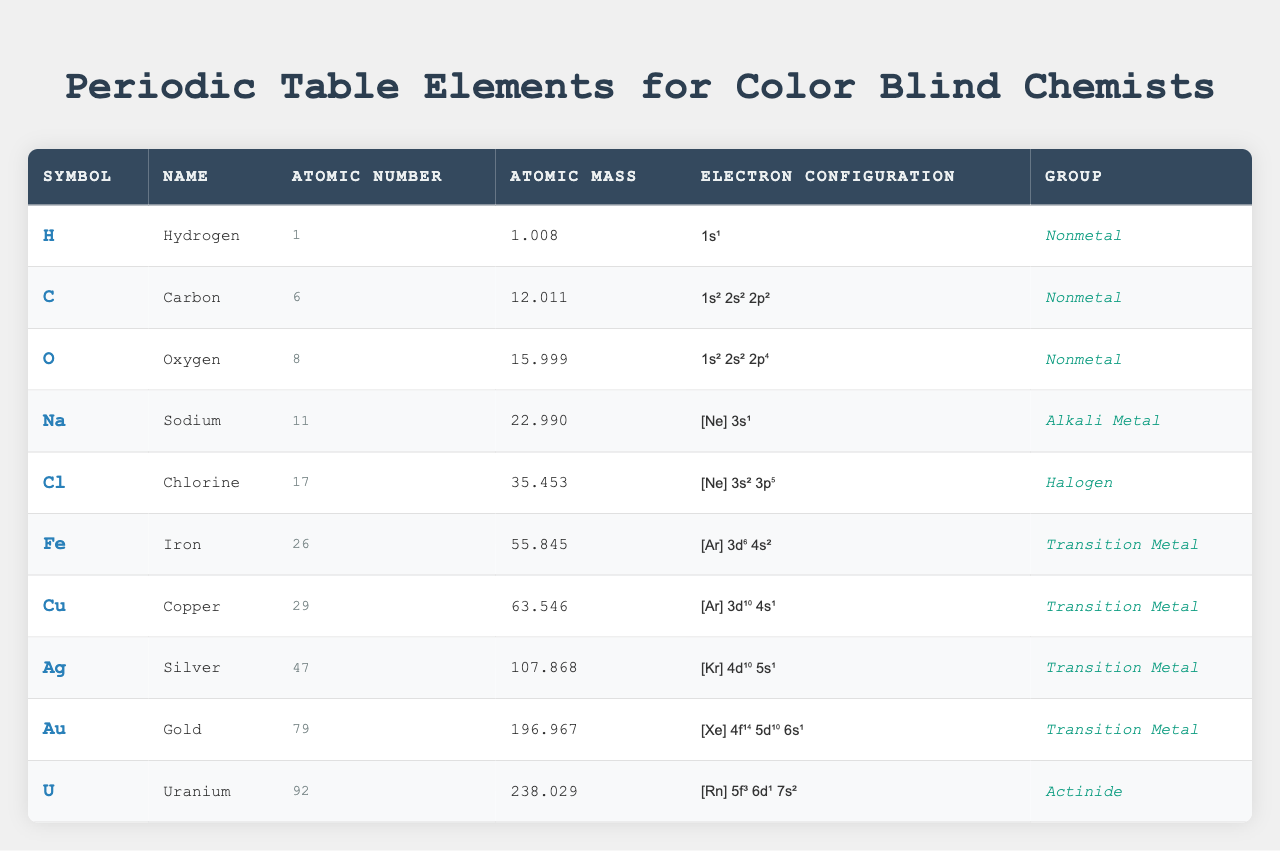What is the atomic mass of Carbon? The atomic mass is listed directly in the table for Carbon, which is 12.011.
Answer: 12.011 Which element has the highest atomic number? By scanning the atomic number column, Uranium is identified with the atomic number of 92, which is higher than all other listed elements.
Answer: Uranium Is Silver a Transition Metal? The group classification for Silver in the table indicates that it is categorized as a Transition Metal.
Answer: Yes What is the electron configuration of Sodium? Looking at the electron configuration column for Sodium, the configuration is listed as [Ne] 3s¹.
Answer: [Ne] 3s¹ Which element has an atomic mass closest to 64? Examining the atomic mass column, Copper is the closest to 64 with its atomic mass of 63.546.
Answer: Copper What is the difference in atomic mass between Iron and Gold? The atomic mass of Iron is 55.845 and that of Gold is 196.967. The difference is calculated as 196.967 - 55.845 = 141.122.
Answer: 141.122 List the nonmetals present in the table. The elements categorized as Nonmetals according to the group classification are Hydrogen, Carbon, and Oxygen.
Answer: Hydrogen, Carbon, and Oxygen What is the average atomic mass of the elements in the table? The atomic masses are: 1.008 (H), 12.011 (C), 15.999 (O), 22.990 (Na), 35.453 (Cl), 55.845 (Fe), 63.546 (Cu), 107.868 (Ag), 196.967 (Au), 238.029 (U). Adding these gives a total of 564.706, and dividing by 10 (the number of elements) results in an average of 56.4706.
Answer: 56.4706 Is Oxygen located in the same group as Chlorine? The table shows that both Oxygen and Chlorine belong to the Nonmetal and Halogen groups, respectively, indicating they are not in the same group.
Answer: No What is the electron configuration of the element with atomic number 79? The element with atomic number 79 is Gold. Its electron configuration as per the table is [Xe] 4f¹⁴ 5d¹⁰ 6s¹.
Answer: [Xe] 4f¹⁴ 5d¹⁰ 6s¹ 